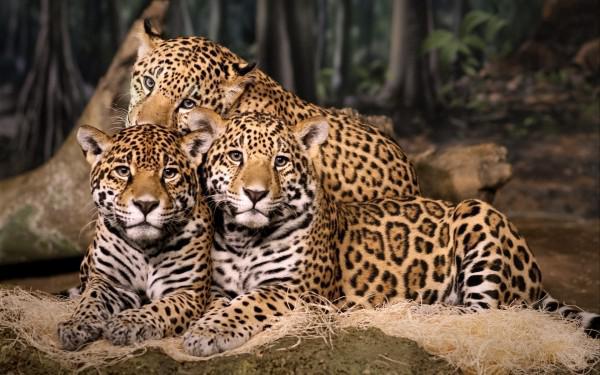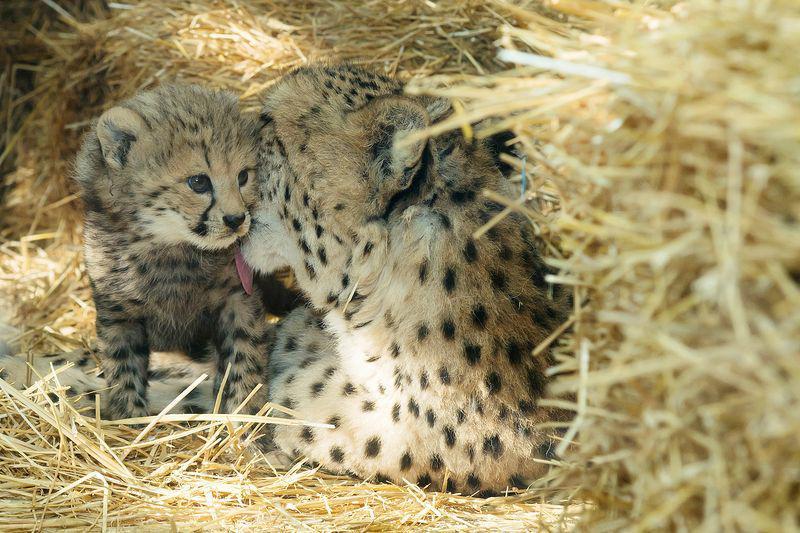The first image is the image on the left, the second image is the image on the right. Assess this claim about the two images: "Each image contains three spotted cats, and at least some of the cats are not reclining.". Correct or not? Answer yes or no. No. 